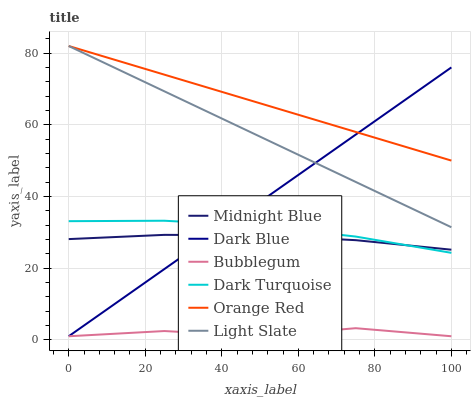Does Bubblegum have the minimum area under the curve?
Answer yes or no. Yes. Does Orange Red have the maximum area under the curve?
Answer yes or no. Yes. Does Light Slate have the minimum area under the curve?
Answer yes or no. No. Does Light Slate have the maximum area under the curve?
Answer yes or no. No. Is Light Slate the smoothest?
Answer yes or no. Yes. Is Bubblegum the roughest?
Answer yes or no. Yes. Is Dark Turquoise the smoothest?
Answer yes or no. No. Is Dark Turquoise the roughest?
Answer yes or no. No. Does Bubblegum have the lowest value?
Answer yes or no. Yes. Does Light Slate have the lowest value?
Answer yes or no. No. Does Orange Red have the highest value?
Answer yes or no. Yes. Does Dark Turquoise have the highest value?
Answer yes or no. No. Is Dark Turquoise less than Light Slate?
Answer yes or no. Yes. Is Orange Red greater than Midnight Blue?
Answer yes or no. Yes. Does Dark Turquoise intersect Dark Blue?
Answer yes or no. Yes. Is Dark Turquoise less than Dark Blue?
Answer yes or no. No. Is Dark Turquoise greater than Dark Blue?
Answer yes or no. No. Does Dark Turquoise intersect Light Slate?
Answer yes or no. No. 